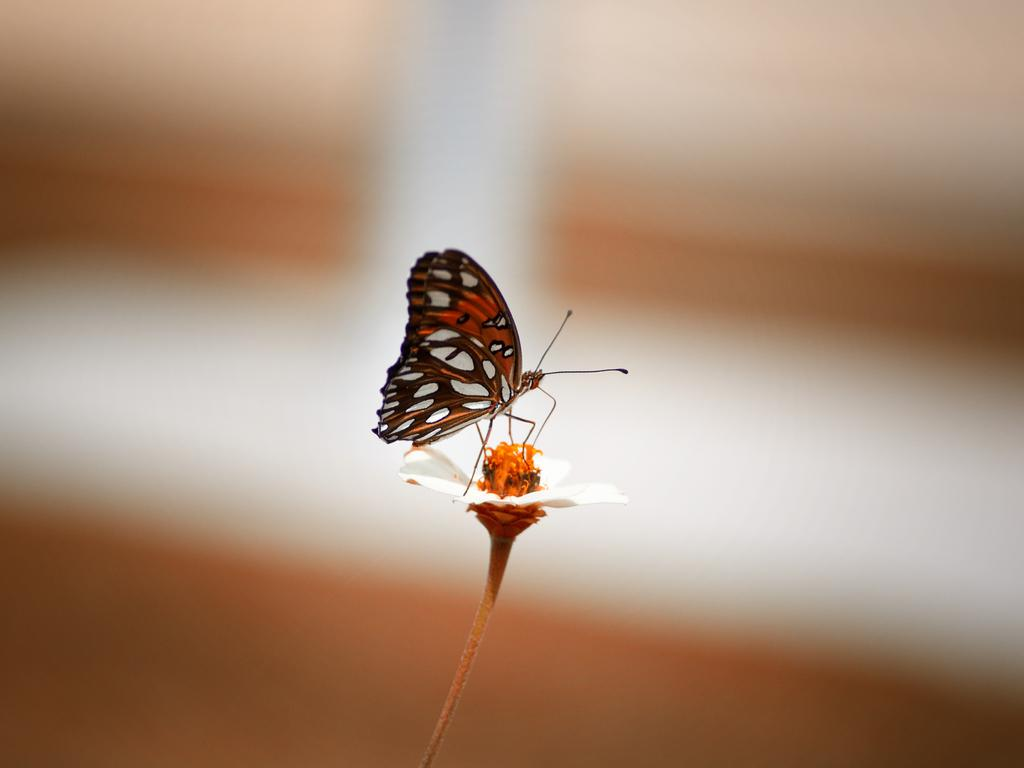What is the main subject of the picture? The main subject of the picture is a butterfly. Where is the butterfly located in the picture? The butterfly is on a flower. What is the flower situated in? The flower is in water. What can be said about the color of the flower? The flower is in color. What colors can be seen on the butterfly? The butterfly is brown and white in color. Can you tell me how the stranger is involved in the fight in the image? There is no stranger or fight depicted in the image; it features a butterfly on a flower in water. 